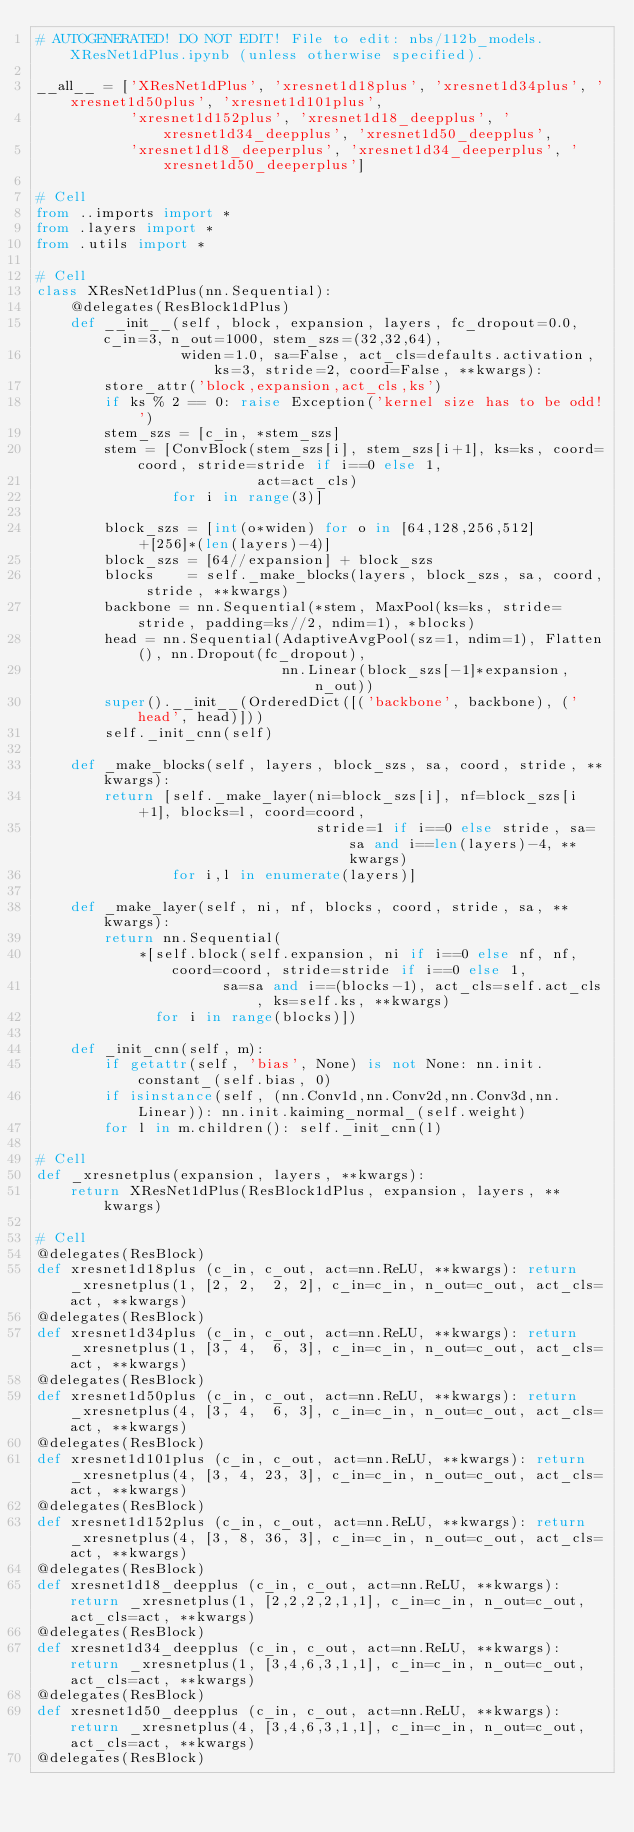<code> <loc_0><loc_0><loc_500><loc_500><_Python_># AUTOGENERATED! DO NOT EDIT! File to edit: nbs/112b_models.XResNet1dPlus.ipynb (unless otherwise specified).

__all__ = ['XResNet1dPlus', 'xresnet1d18plus', 'xresnet1d34plus', 'xresnet1d50plus', 'xresnet1d101plus',
           'xresnet1d152plus', 'xresnet1d18_deepplus', 'xresnet1d34_deepplus', 'xresnet1d50_deepplus',
           'xresnet1d18_deeperplus', 'xresnet1d34_deeperplus', 'xresnet1d50_deeperplus']

# Cell
from ..imports import *
from .layers import *
from .utils import *

# Cell
class XResNet1dPlus(nn.Sequential):
    @delegates(ResBlock1dPlus)
    def __init__(self, block, expansion, layers, fc_dropout=0.0, c_in=3, n_out=1000, stem_szs=(32,32,64),
                 widen=1.0, sa=False, act_cls=defaults.activation, ks=3, stride=2, coord=False, **kwargs):
        store_attr('block,expansion,act_cls,ks')
        if ks % 2 == 0: raise Exception('kernel size has to be odd!')
        stem_szs = [c_in, *stem_szs]
        stem = [ConvBlock(stem_szs[i], stem_szs[i+1], ks=ks, coord=coord, stride=stride if i==0 else 1,
                          act=act_cls)
                for i in range(3)]

        block_szs = [int(o*widen) for o in [64,128,256,512] +[256]*(len(layers)-4)]
        block_szs = [64//expansion] + block_szs
        blocks    = self._make_blocks(layers, block_szs, sa, coord, stride, **kwargs)
        backbone = nn.Sequential(*stem, MaxPool(ks=ks, stride=stride, padding=ks//2, ndim=1), *blocks)
        head = nn.Sequential(AdaptiveAvgPool(sz=1, ndim=1), Flatten(), nn.Dropout(fc_dropout),
                             nn.Linear(block_szs[-1]*expansion, n_out))
        super().__init__(OrderedDict([('backbone', backbone), ('head', head)]))
        self._init_cnn(self)

    def _make_blocks(self, layers, block_szs, sa, coord, stride, **kwargs):
        return [self._make_layer(ni=block_szs[i], nf=block_szs[i+1], blocks=l, coord=coord,
                                 stride=1 if i==0 else stride, sa=sa and i==len(layers)-4, **kwargs)
                for i,l in enumerate(layers)]

    def _make_layer(self, ni, nf, blocks, coord, stride, sa, **kwargs):
        return nn.Sequential(
            *[self.block(self.expansion, ni if i==0 else nf, nf, coord=coord, stride=stride if i==0 else 1,
                      sa=sa and i==(blocks-1), act_cls=self.act_cls, ks=self.ks, **kwargs)
              for i in range(blocks)])

    def _init_cnn(self, m):
        if getattr(self, 'bias', None) is not None: nn.init.constant_(self.bias, 0)
        if isinstance(self, (nn.Conv1d,nn.Conv2d,nn.Conv3d,nn.Linear)): nn.init.kaiming_normal_(self.weight)
        for l in m.children(): self._init_cnn(l)

# Cell
def _xresnetplus(expansion, layers, **kwargs):
    return XResNet1dPlus(ResBlock1dPlus, expansion, layers, **kwargs)

# Cell
@delegates(ResBlock)
def xresnet1d18plus (c_in, c_out, act=nn.ReLU, **kwargs): return _xresnetplus(1, [2, 2,  2, 2], c_in=c_in, n_out=c_out, act_cls=act, **kwargs)
@delegates(ResBlock)
def xresnet1d34plus (c_in, c_out, act=nn.ReLU, **kwargs): return _xresnetplus(1, [3, 4,  6, 3], c_in=c_in, n_out=c_out, act_cls=act, **kwargs)
@delegates(ResBlock)
def xresnet1d50plus (c_in, c_out, act=nn.ReLU, **kwargs): return _xresnetplus(4, [3, 4,  6, 3], c_in=c_in, n_out=c_out, act_cls=act, **kwargs)
@delegates(ResBlock)
def xresnet1d101plus (c_in, c_out, act=nn.ReLU, **kwargs): return _xresnetplus(4, [3, 4, 23, 3], c_in=c_in, n_out=c_out, act_cls=act, **kwargs)
@delegates(ResBlock)
def xresnet1d152plus (c_in, c_out, act=nn.ReLU, **kwargs): return _xresnetplus(4, [3, 8, 36, 3], c_in=c_in, n_out=c_out, act_cls=act, **kwargs)
@delegates(ResBlock)
def xresnet1d18_deepplus (c_in, c_out, act=nn.ReLU, **kwargs): return _xresnetplus(1, [2,2,2,2,1,1], c_in=c_in, n_out=c_out, act_cls=act, **kwargs)
@delegates(ResBlock)
def xresnet1d34_deepplus (c_in, c_out, act=nn.ReLU, **kwargs): return _xresnetplus(1, [3,4,6,3,1,1], c_in=c_in, n_out=c_out, act_cls=act, **kwargs)
@delegates(ResBlock)
def xresnet1d50_deepplus (c_in, c_out, act=nn.ReLU, **kwargs): return _xresnetplus(4, [3,4,6,3,1,1], c_in=c_in, n_out=c_out, act_cls=act, **kwargs)
@delegates(ResBlock)</code> 